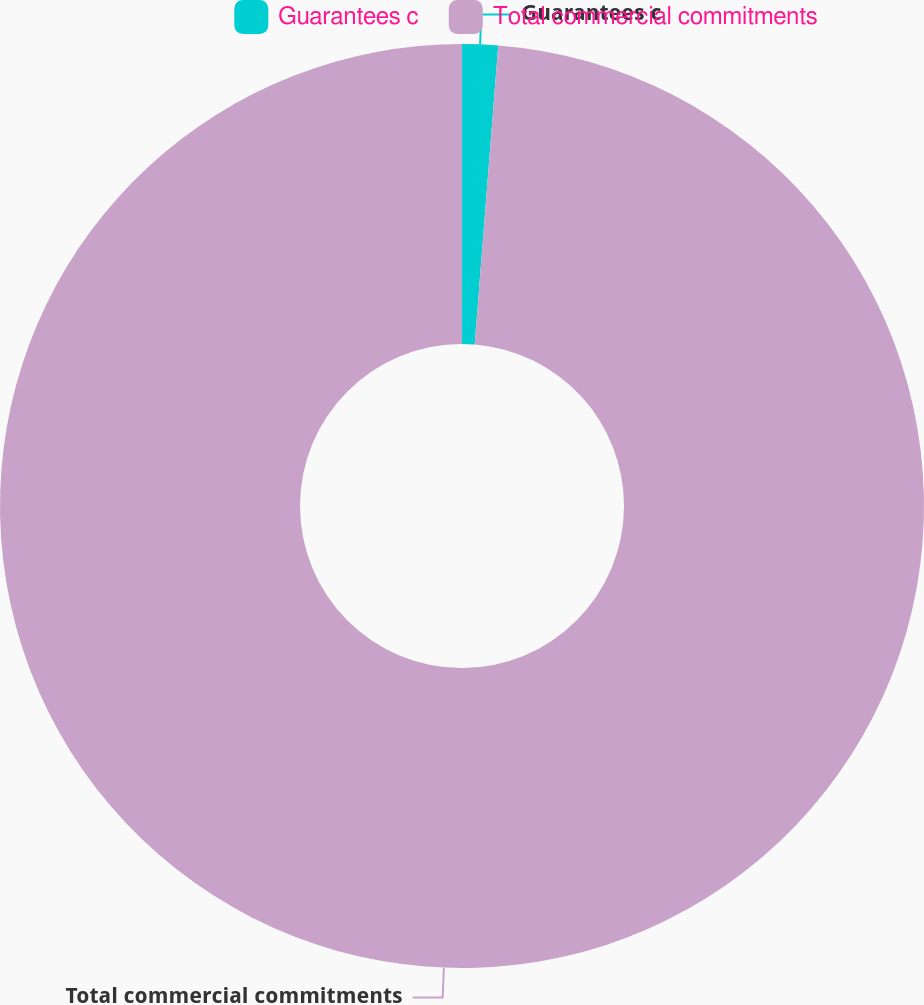<chart> <loc_0><loc_0><loc_500><loc_500><pie_chart><fcel>Guarantees c<fcel>Total commercial commitments<nl><fcel>1.25%<fcel>98.75%<nl></chart> 